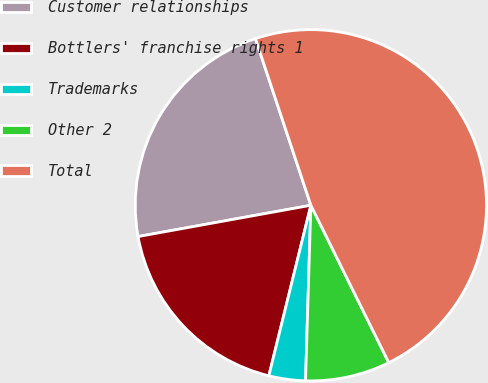Convert chart to OTSL. <chart><loc_0><loc_0><loc_500><loc_500><pie_chart><fcel>Customer relationships<fcel>Bottlers' franchise rights 1<fcel>Trademarks<fcel>Other 2<fcel>Total<nl><fcel>22.74%<fcel>18.3%<fcel>3.36%<fcel>7.8%<fcel>47.79%<nl></chart> 